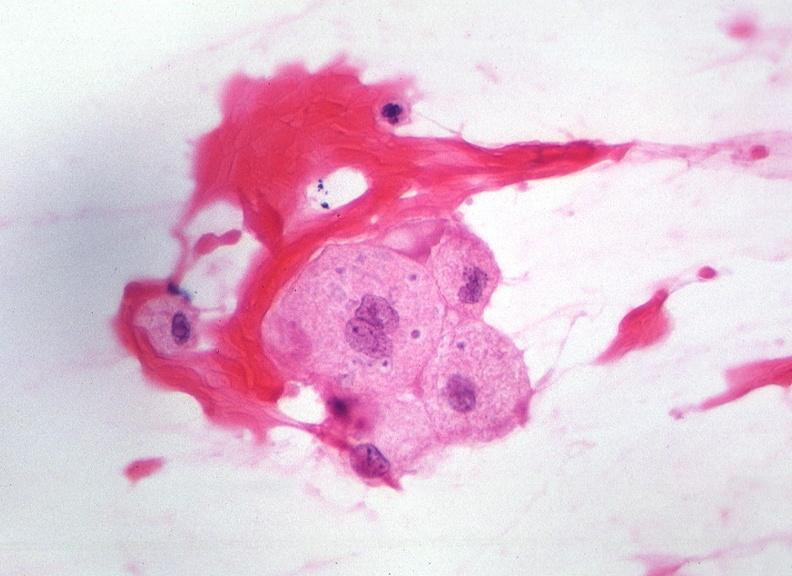what is present?
Answer the question using a single word or phrase. Nervous 